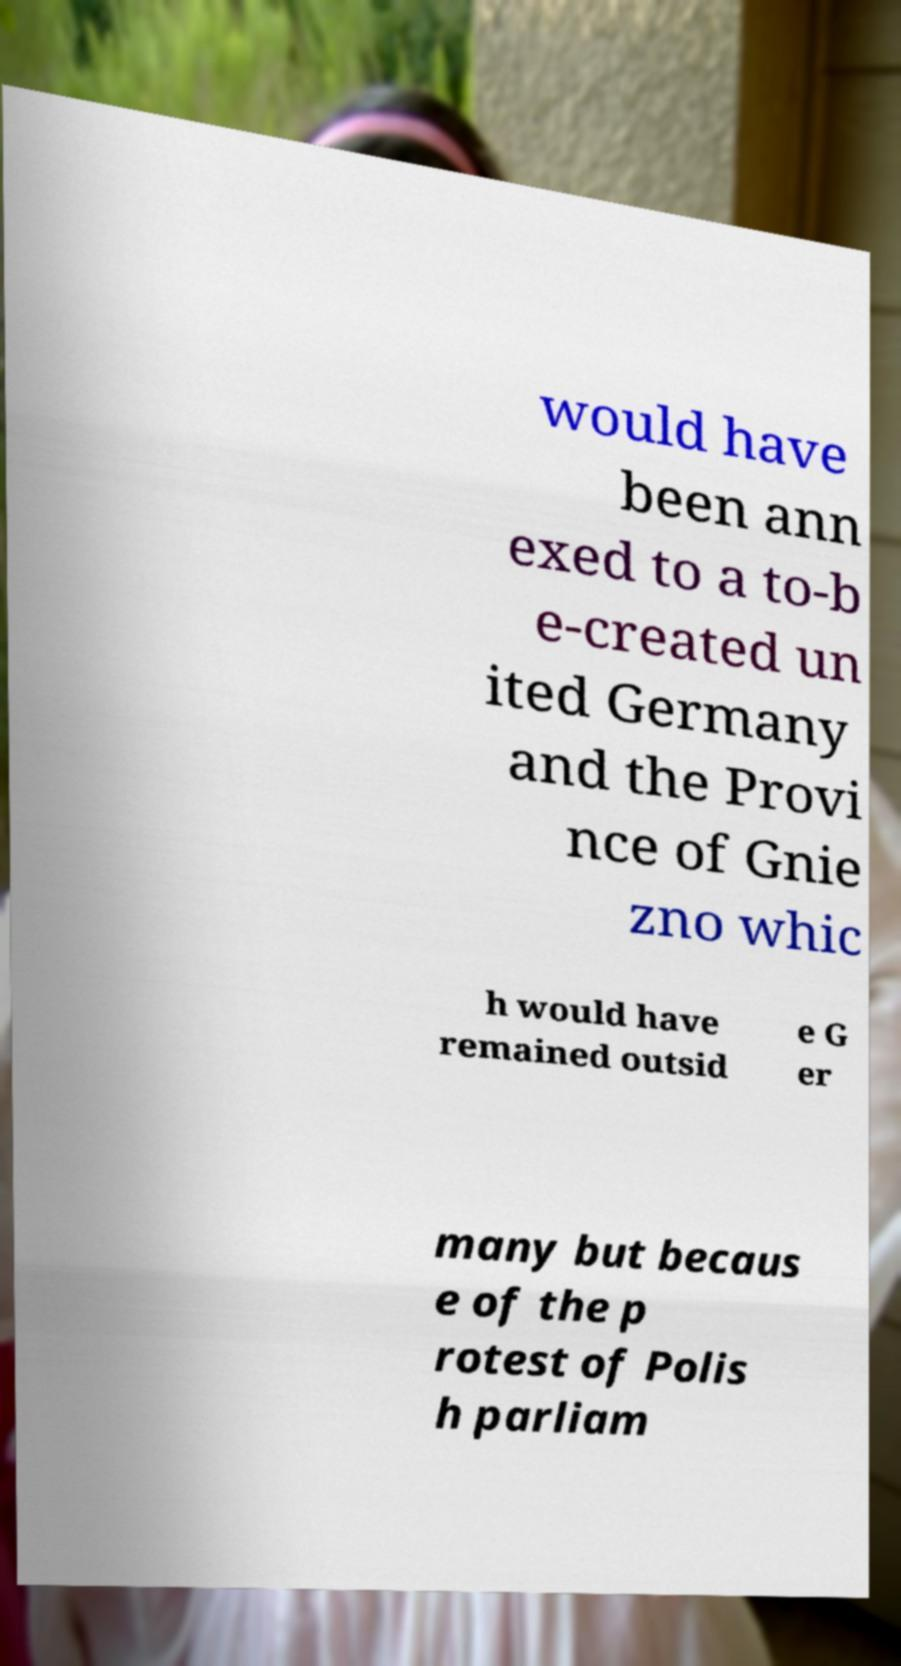Can you accurately transcribe the text from the provided image for me? would have been ann exed to a to-b e-created un ited Germany and the Provi nce of Gnie zno whic h would have remained outsid e G er many but becaus e of the p rotest of Polis h parliam 